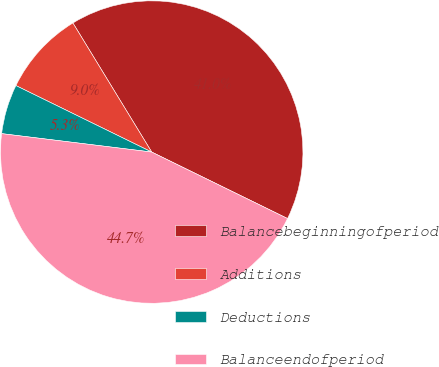Convert chart to OTSL. <chart><loc_0><loc_0><loc_500><loc_500><pie_chart><fcel>Balancebeginningofperiod<fcel>Additions<fcel>Deductions<fcel>Balanceendofperiod<nl><fcel>40.97%<fcel>9.03%<fcel>5.3%<fcel>44.7%<nl></chart> 